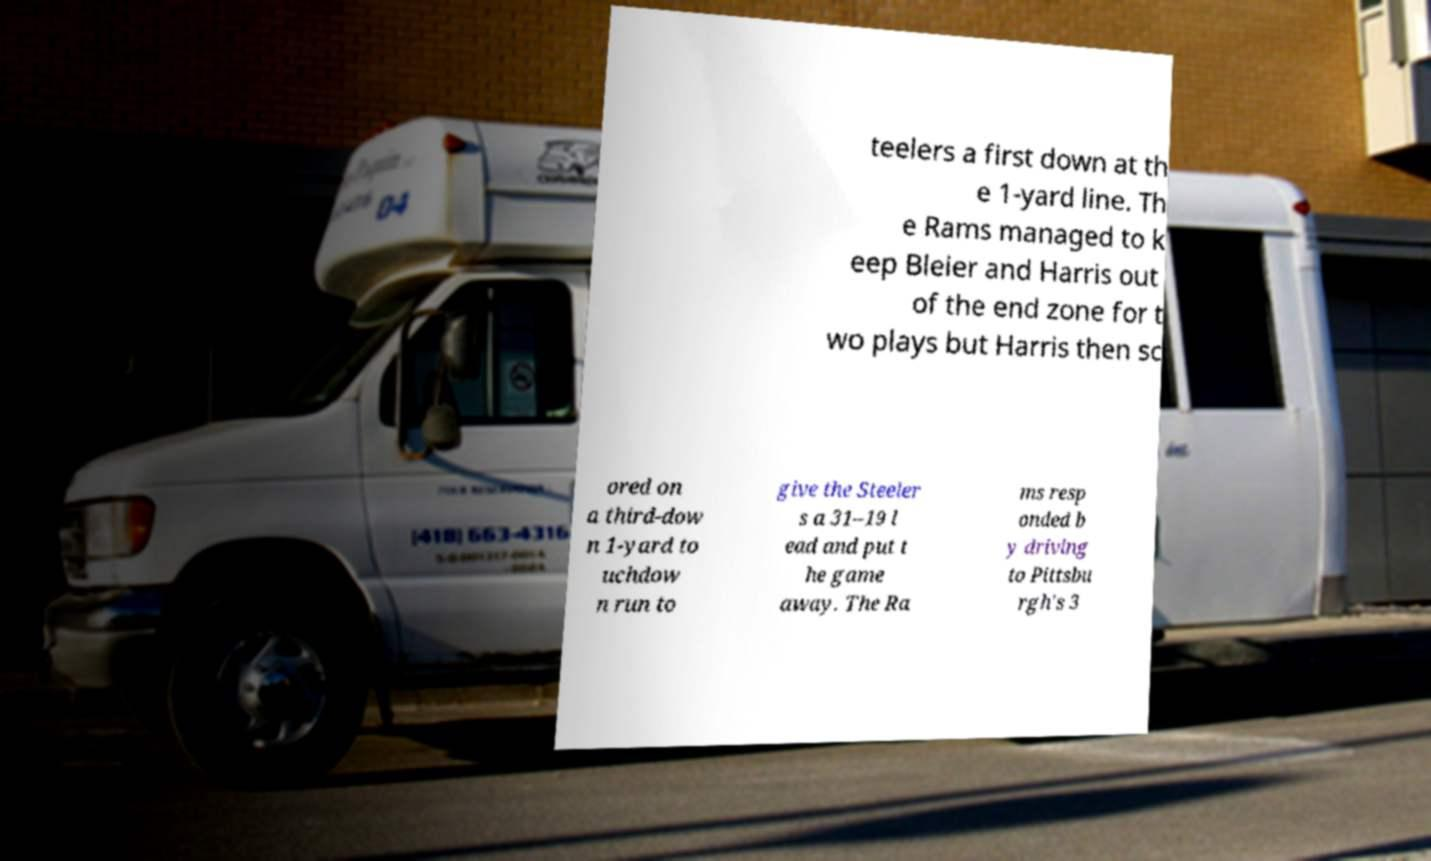Can you accurately transcribe the text from the provided image for me? teelers a first down at th e 1-yard line. Th e Rams managed to k eep Bleier and Harris out of the end zone for t wo plays but Harris then sc ored on a third-dow n 1-yard to uchdow n run to give the Steeler s a 31–19 l ead and put t he game away. The Ra ms resp onded b y driving to Pittsbu rgh's 3 